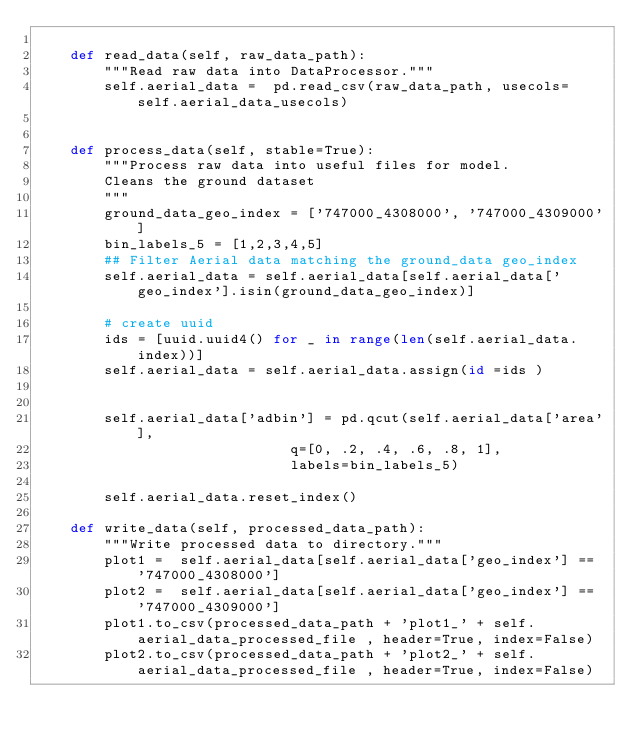<code> <loc_0><loc_0><loc_500><loc_500><_Python_>
    def read_data(self, raw_data_path):
        """Read raw data into DataProcessor."""
        self.aerial_data =  pd.read_csv(raw_data_path, usecols= self.aerial_data_usecols)


    def process_data(self, stable=True):
        """Process raw data into useful files for model.
        Cleans the ground dataset
        """
        ground_data_geo_index = ['747000_4308000', '747000_4309000']
        bin_labels_5 = [1,2,3,4,5]
        ## Filter Aerial data matching the ground_data geo_index
        self.aerial_data = self.aerial_data[self.aerial_data['geo_index'].isin(ground_data_geo_index)]
        
        # create uuid
        ids = [uuid.uuid4() for _ in range(len(self.aerial_data.index))]
        self.aerial_data = self.aerial_data.assign(id =ids )

        
        self.aerial_data['adbin'] = pd.qcut(self.aerial_data['area'],
                              q=[0, .2, .4, .6, .8, 1],
                              labels=bin_labels_5)

        self.aerial_data.reset_index()

    def write_data(self, processed_data_path):
        """Write processed data to directory."""
        plot1 =  self.aerial_data[self.aerial_data['geo_index'] == '747000_4308000']
        plot2 =  self.aerial_data[self.aerial_data['geo_index'] == '747000_4309000']
        plot1.to_csv(processed_data_path + 'plot1_' + self.aerial_data_processed_file , header=True, index=False)
        plot2.to_csv(processed_data_path + 'plot2_' + self.aerial_data_processed_file , header=True, index=False)
        
    
</code> 